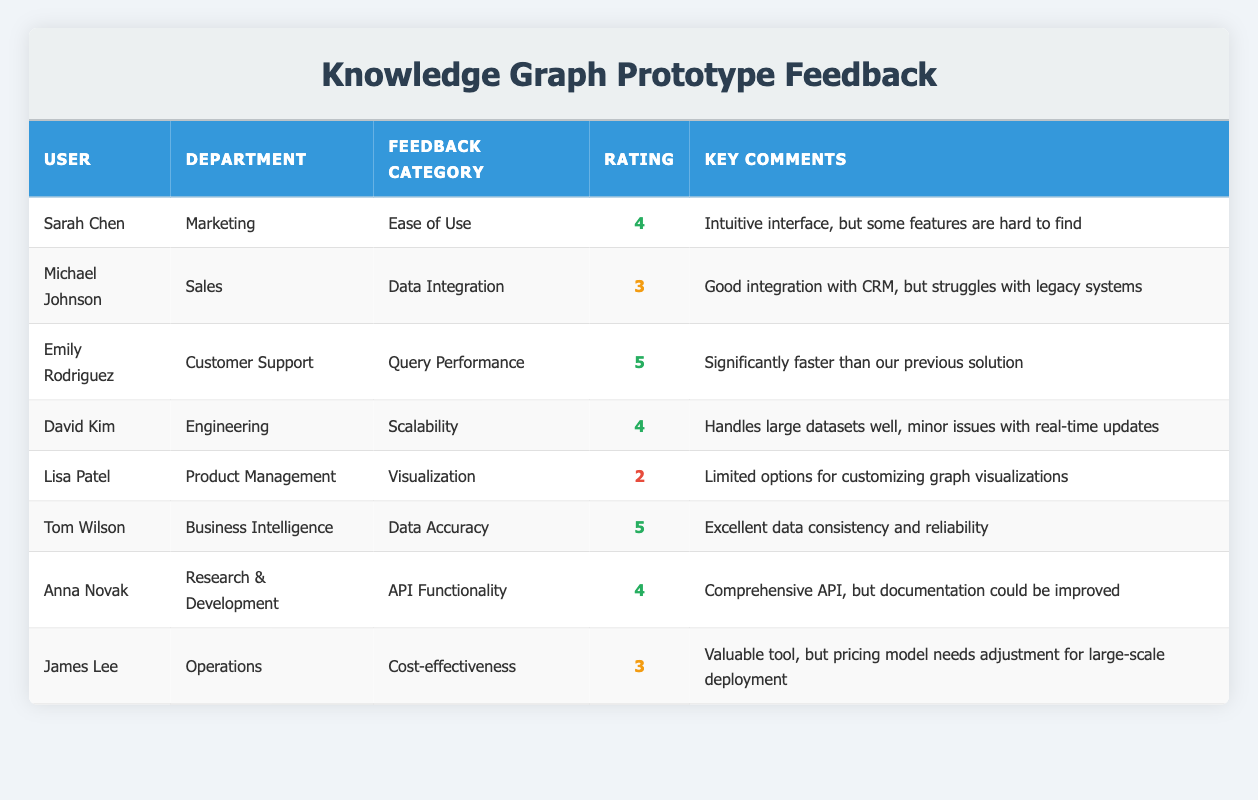What feedback category received the highest rating? The ratings in the "Rating" column show that "Query Performance" and "Data Accuracy" both have a rating of 5, making them the highest ratings.
Answer: Query Performance and Data Accuracy What is the average rating across all feedback categories? To find the average rating, sum all the ratings (4 + 3 + 5 + 4 + 2 + 5 + 4 + 3 = 30) and divide by the number of responses (8). The average rating is 30/8 = 3.75.
Answer: 3.75 Which user provided feedback on the visualization category? The "User" column indicates that Lisa Patel provided feedback in the "Visualization" category with a rating of 2.
Answer: Lisa Patel Did any user give a rating of 2? Yes, Lisa Patel's feedback on the Visualization category received a rating of 2.
Answer: Yes What is the key comment from Tom Wilson in Business Intelligence? By looking at the "Key Comments" for Tom Wilson, it states that he mentioned "Excellent data consistency and reliability."
Answer: Excellent data consistency and reliability Which department had the lowest-rated feedback category? Evaluating all ratings, the "Visualization" category had the lowest rating of 2, provided by the Product Management department.
Answer: Product Management How many users rated the ease of use 4 or higher? The users who rated "Ease of Use" 4 or higher are Sarah Chen (4), Emily Rodriguez (5), David Kim (4), and Anna Novak (4). That totals 4 users.
Answer: 4 What issue did Michael Johnson highlight regarding data integration? Michael Johnson highlighted a struggle with legacy systems despite good integration with CRM.
Answer: Struggles with legacy systems In the context of cost-effectiveness, what feedback did James Lee provide? James Lee noted that the tool is valuable but mentioned that the pricing model needs adjustment for large-scale deployment.
Answer: Needs adjustment for large-scale deployment 